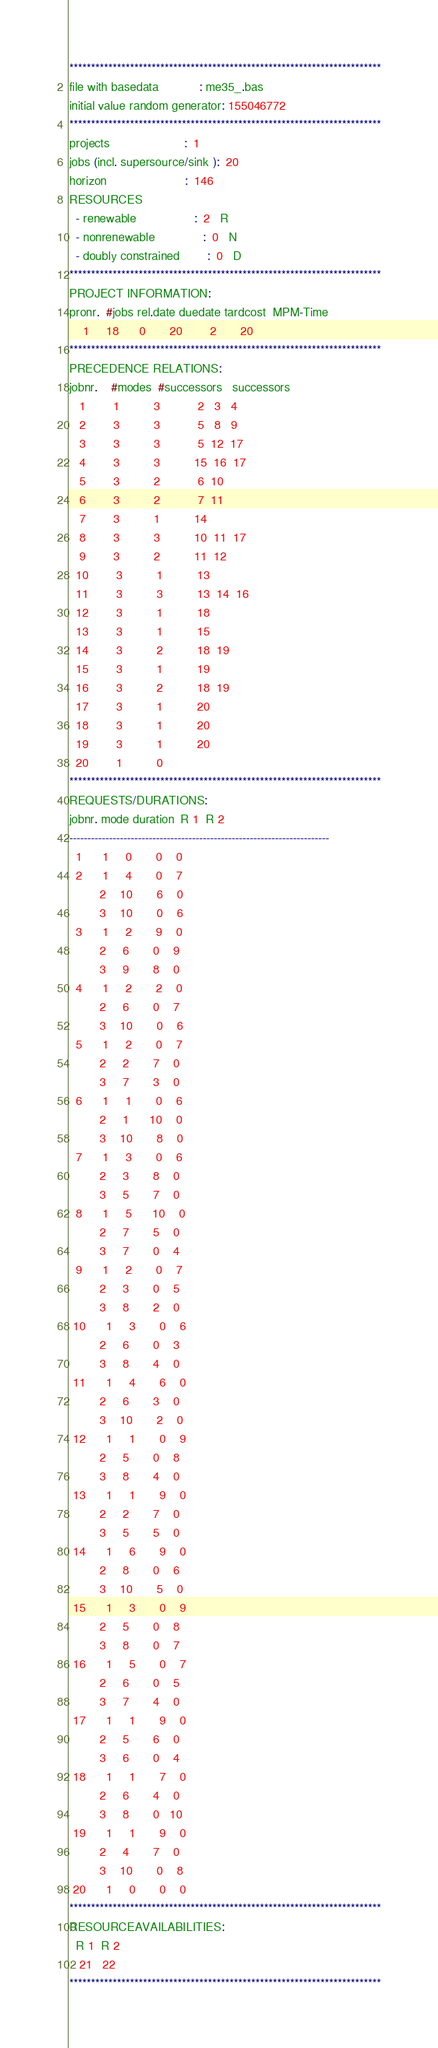Convert code to text. <code><loc_0><loc_0><loc_500><loc_500><_ObjectiveC_>************************************************************************
file with basedata            : me35_.bas
initial value random generator: 155046772
************************************************************************
projects                      :  1
jobs (incl. supersource/sink ):  20
horizon                       :  146
RESOURCES
  - renewable                 :  2   R
  - nonrenewable              :  0   N
  - doubly constrained        :  0   D
************************************************************************
PROJECT INFORMATION:
pronr.  #jobs rel.date duedate tardcost  MPM-Time
    1     18      0       20        2       20
************************************************************************
PRECEDENCE RELATIONS:
jobnr.    #modes  #successors   successors
   1        1          3           2   3   4
   2        3          3           5   8   9
   3        3          3           5  12  17
   4        3          3          15  16  17
   5        3          2           6  10
   6        3          2           7  11
   7        3          1          14
   8        3          3          10  11  17
   9        3          2          11  12
  10        3          1          13
  11        3          3          13  14  16
  12        3          1          18
  13        3          1          15
  14        3          2          18  19
  15        3          1          19
  16        3          2          18  19
  17        3          1          20
  18        3          1          20
  19        3          1          20
  20        1          0        
************************************************************************
REQUESTS/DURATIONS:
jobnr. mode duration  R 1  R 2
------------------------------------------------------------------------
  1      1     0       0    0
  2      1     4       0    7
         2    10       6    0
         3    10       0    6
  3      1     2       9    0
         2     6       0    9
         3     9       8    0
  4      1     2       2    0
         2     6       0    7
         3    10       0    6
  5      1     2       0    7
         2     2       7    0
         3     7       3    0
  6      1     1       0    6
         2     1      10    0
         3    10       8    0
  7      1     3       0    6
         2     3       8    0
         3     5       7    0
  8      1     5      10    0
         2     7       5    0
         3     7       0    4
  9      1     2       0    7
         2     3       0    5
         3     8       2    0
 10      1     3       0    6
         2     6       0    3
         3     8       4    0
 11      1     4       6    0
         2     6       3    0
         3    10       2    0
 12      1     1       0    9
         2     5       0    8
         3     8       4    0
 13      1     1       9    0
         2     2       7    0
         3     5       5    0
 14      1     6       9    0
         2     8       0    6
         3    10       5    0
 15      1     3       0    9
         2     5       0    8
         3     8       0    7
 16      1     5       0    7
         2     6       0    5
         3     7       4    0
 17      1     1       9    0
         2     5       6    0
         3     6       0    4
 18      1     1       7    0
         2     6       4    0
         3     8       0   10
 19      1     1       9    0
         2     4       7    0
         3    10       0    8
 20      1     0       0    0
************************************************************************
RESOURCEAVAILABILITIES:
  R 1  R 2
   21   22
************************************************************************
</code> 